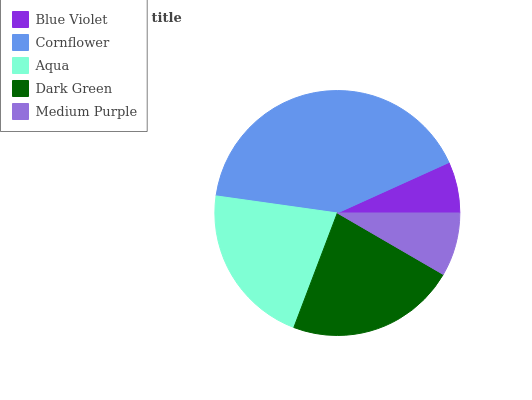Is Blue Violet the minimum?
Answer yes or no. Yes. Is Cornflower the maximum?
Answer yes or no. Yes. Is Aqua the minimum?
Answer yes or no. No. Is Aqua the maximum?
Answer yes or no. No. Is Cornflower greater than Aqua?
Answer yes or no. Yes. Is Aqua less than Cornflower?
Answer yes or no. Yes. Is Aqua greater than Cornflower?
Answer yes or no. No. Is Cornflower less than Aqua?
Answer yes or no. No. Is Aqua the high median?
Answer yes or no. Yes. Is Aqua the low median?
Answer yes or no. Yes. Is Blue Violet the high median?
Answer yes or no. No. Is Dark Green the low median?
Answer yes or no. No. 